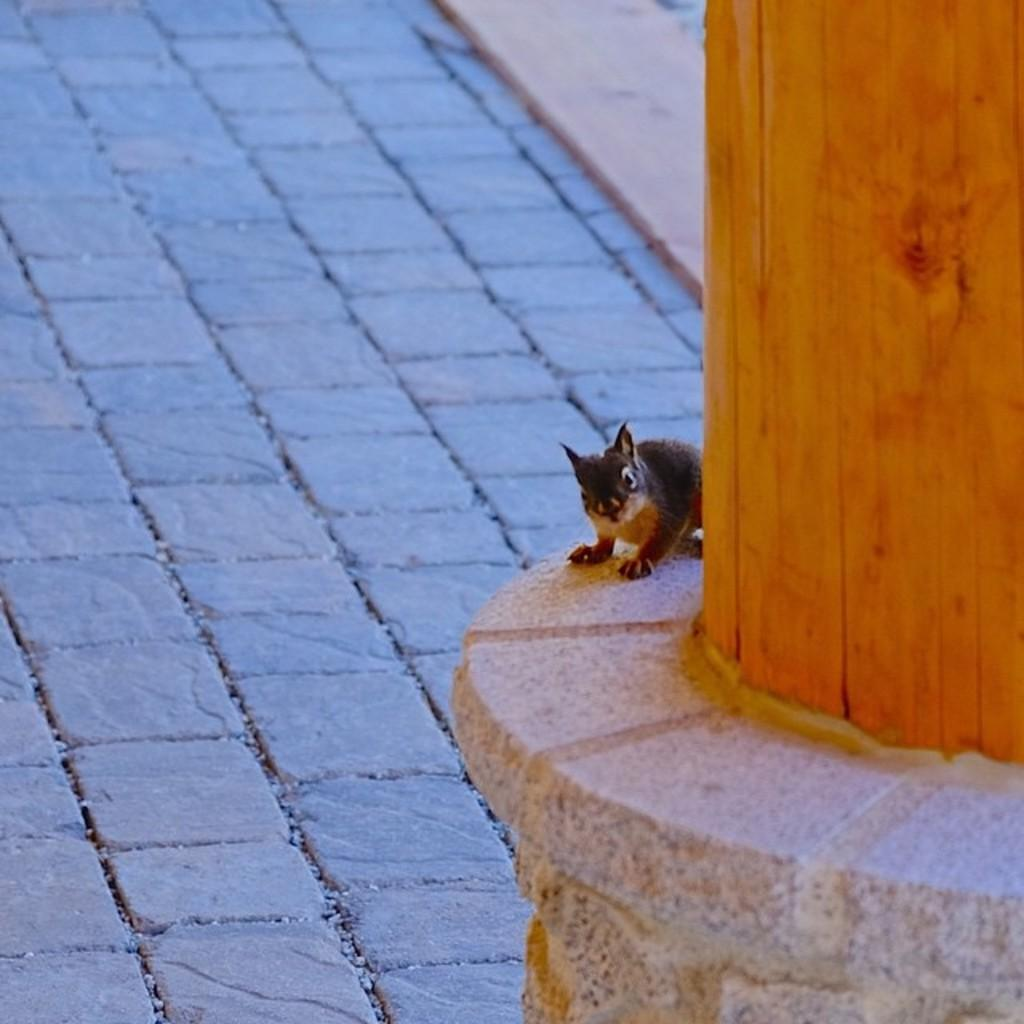What animal can be seen on the right side of the image? There is a squirrel on the right side of the image. Where is the squirrel located? The squirrel is on a pillar. What type of surface can be seen in the background of the image? There is ground visible in the background of the image. What type of paste is being used by the squirrel to climb the pillar in the image? There is no paste present in the image, and the squirrel is not shown climbing the pillar. 